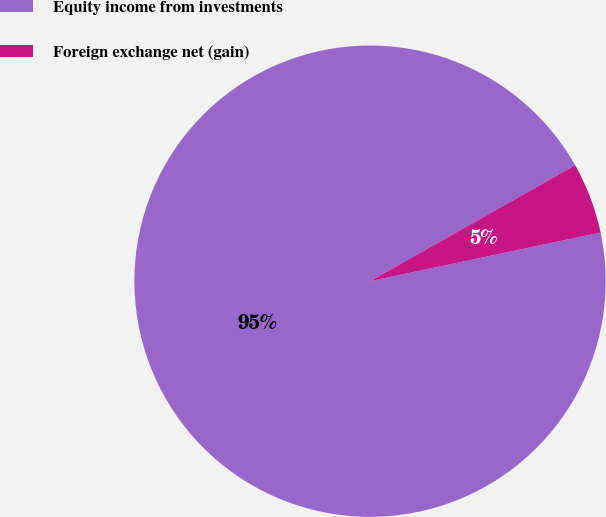Convert chart. <chart><loc_0><loc_0><loc_500><loc_500><pie_chart><fcel>Equity income from investments<fcel>Foreign exchange net (gain)<nl><fcel>95.12%<fcel>4.88%<nl></chart> 